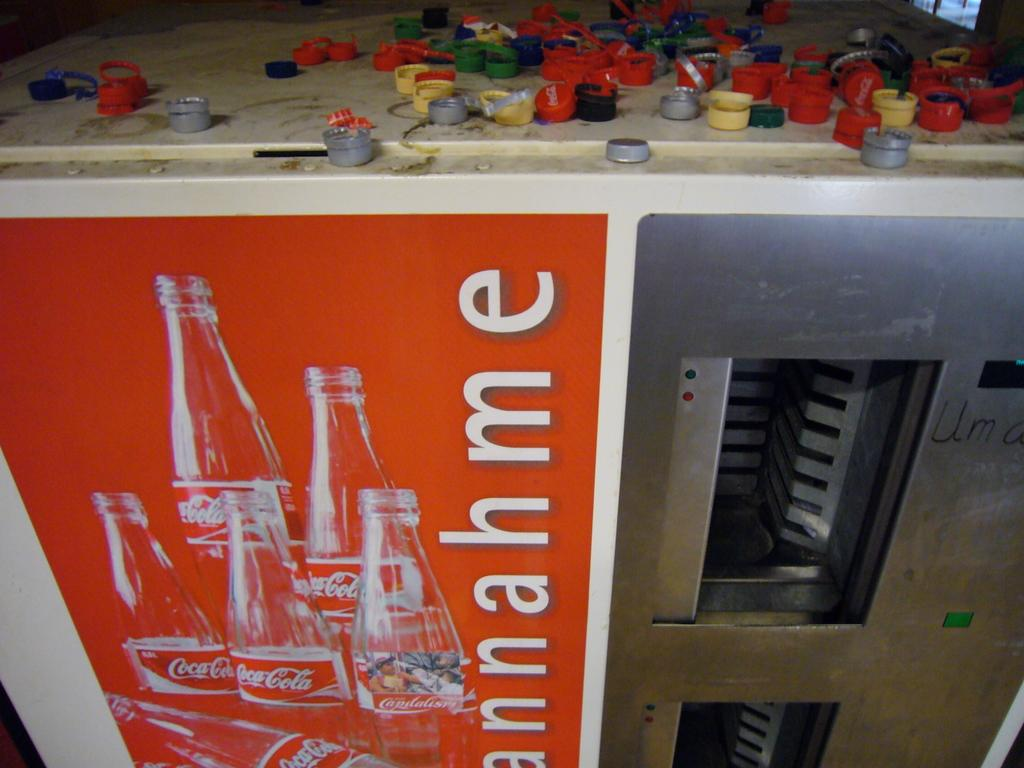<image>
Render a clear and concise summary of the photo. The writing next to the coca cola bottles is unreadable 